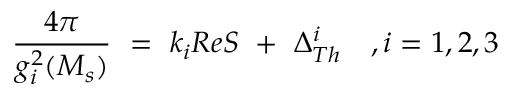Convert formula to latex. <formula><loc_0><loc_0><loc_500><loc_500>{ \frac { 4 \pi } { g _ { i } ^ { 2 } ( M _ { s } ) } } \ = \ k _ { i } R e S \ + \ \Delta _ { T h } ^ { i } \quad , i = 1 , 2 , 3</formula> 